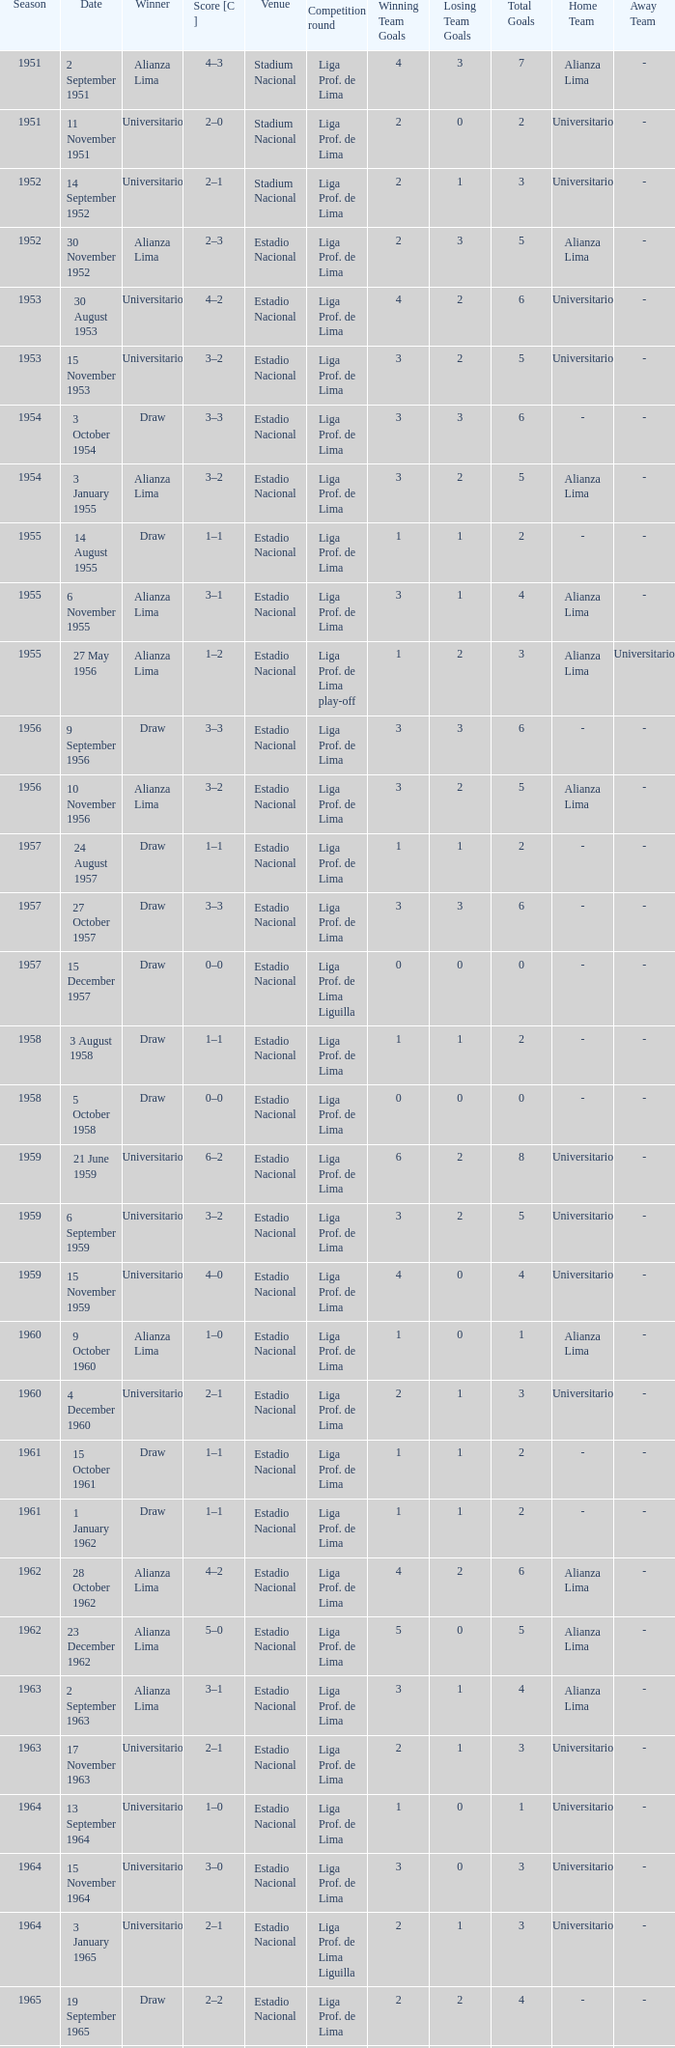What venue had an event on 17 November 1963? Estadio Nacional. 